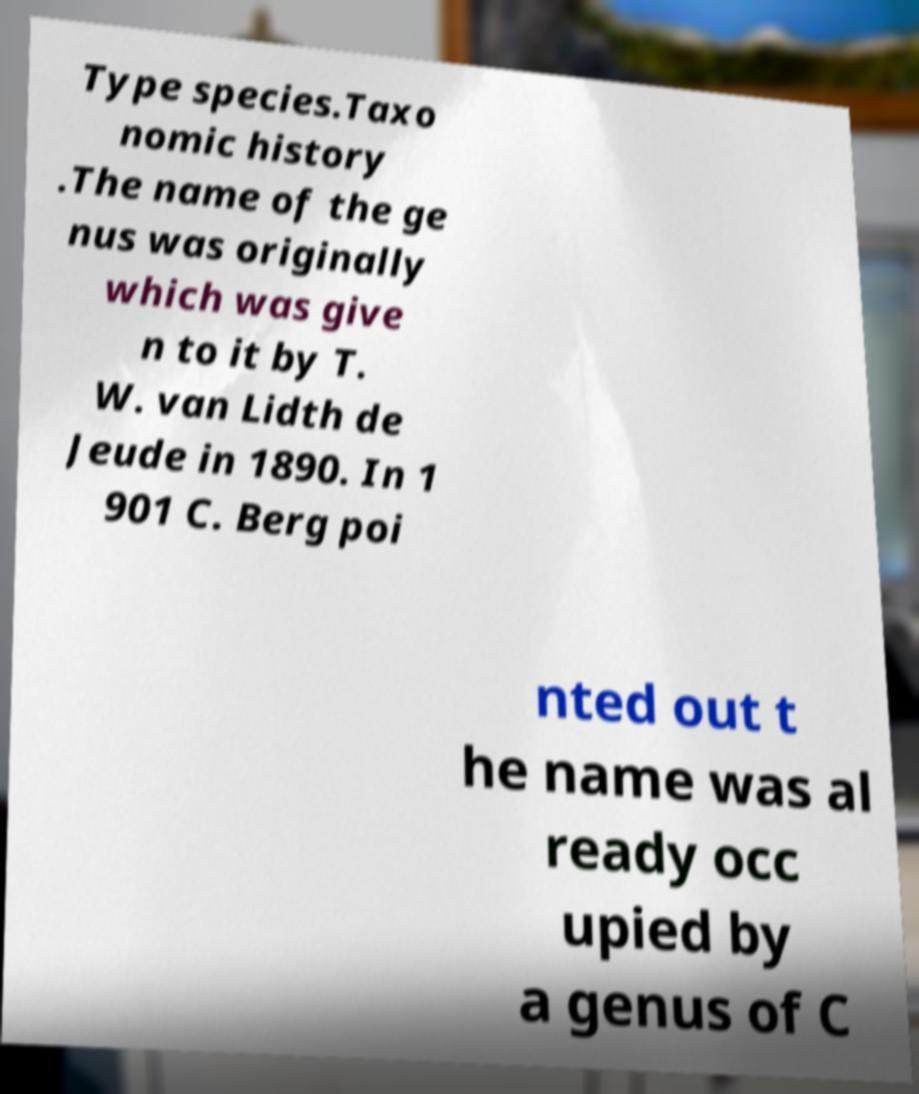Please identify and transcribe the text found in this image. Type species.Taxo nomic history .The name of the ge nus was originally which was give n to it by T. W. van Lidth de Jeude in 1890. In 1 901 C. Berg poi nted out t he name was al ready occ upied by a genus of C 